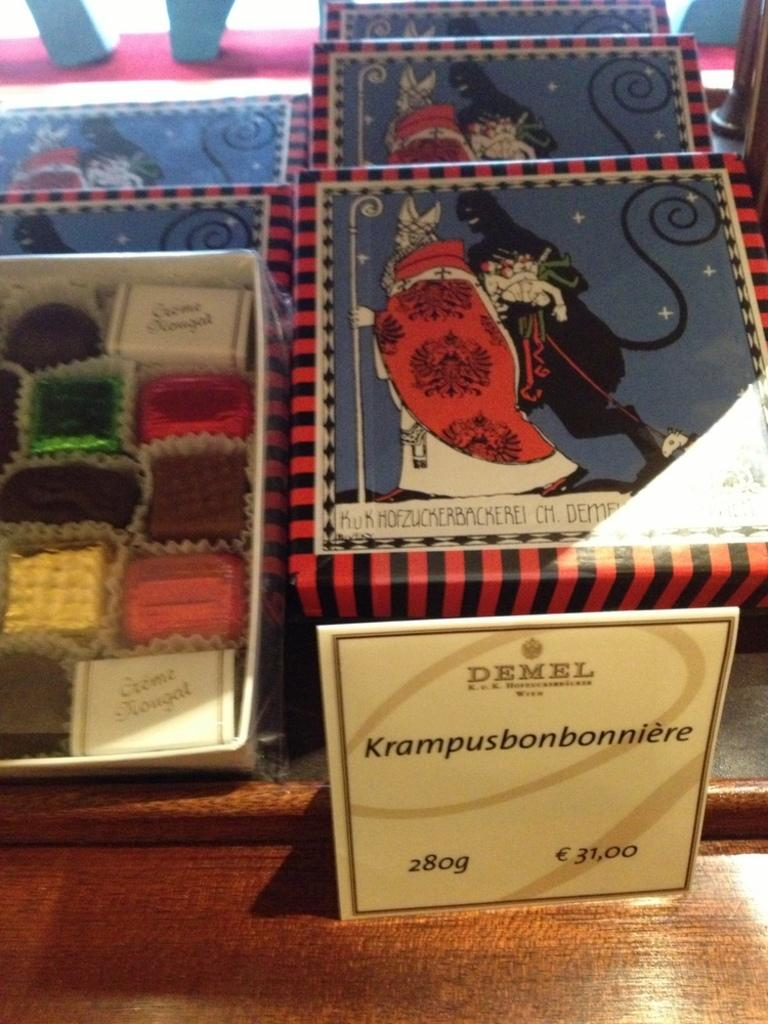<image>
Relay a brief, clear account of the picture shown. Napkins with display that says Demel and lists the price as 31 euros. 